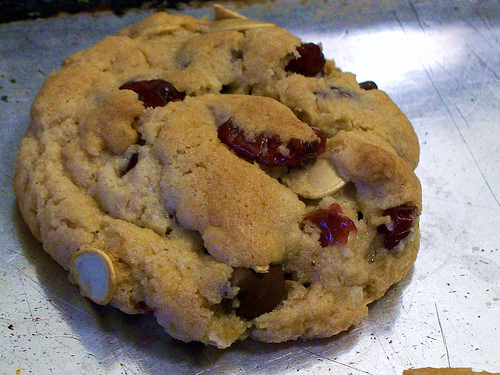<image>
Can you confirm if the butter is on the biscuit? No. The butter is not positioned on the biscuit. They may be near each other, but the butter is not supported by or resting on top of the biscuit. 